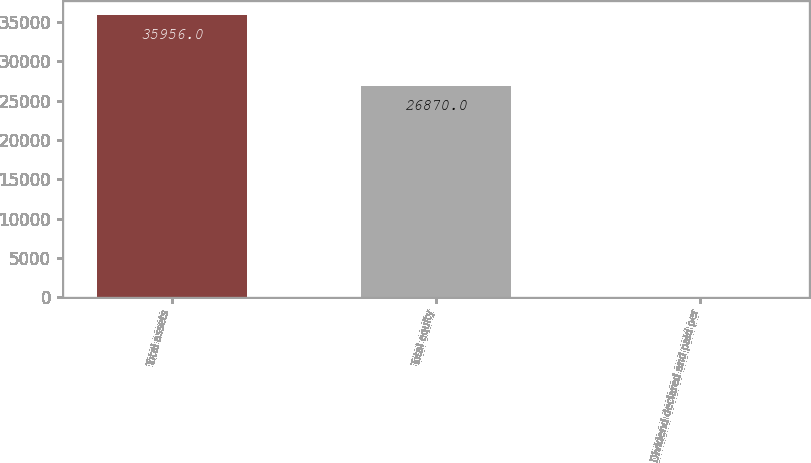Convert chart. <chart><loc_0><loc_0><loc_500><loc_500><bar_chart><fcel>Total assets<fcel>Total equity<fcel>Dividend declared and paid per<nl><fcel>35956<fcel>26870<fcel>1.32<nl></chart> 